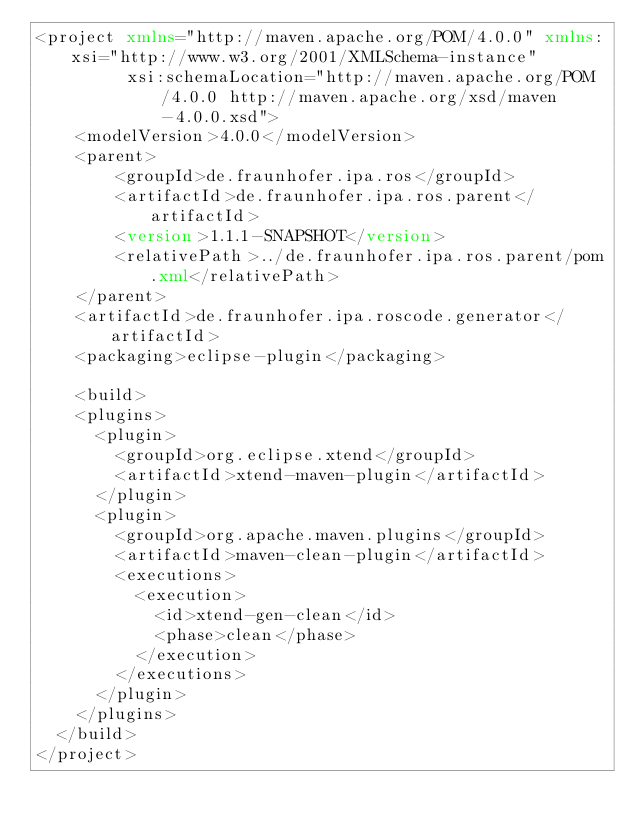<code> <loc_0><loc_0><loc_500><loc_500><_XML_><project xmlns="http://maven.apache.org/POM/4.0.0" xmlns:xsi="http://www.w3.org/2001/XMLSchema-instance"
         xsi:schemaLocation="http://maven.apache.org/POM/4.0.0 http://maven.apache.org/xsd/maven-4.0.0.xsd">
    <modelVersion>4.0.0</modelVersion>
    <parent>
        <groupId>de.fraunhofer.ipa.ros</groupId>
        <artifactId>de.fraunhofer.ipa.ros.parent</artifactId>
        <version>1.1.1-SNAPSHOT</version>
        <relativePath>../de.fraunhofer.ipa.ros.parent/pom.xml</relativePath>
    </parent>
    <artifactId>de.fraunhofer.ipa.roscode.generator</artifactId>
    <packaging>eclipse-plugin</packaging>

    <build>
		<plugins>
			<plugin>
				<groupId>org.eclipse.xtend</groupId>
				<artifactId>xtend-maven-plugin</artifactId>
			</plugin>
			<plugin>
				<groupId>org.apache.maven.plugins</groupId>
				<artifactId>maven-clean-plugin</artifactId>
				<executions>
					<execution>
						<id>xtend-gen-clean</id>
						<phase>clean</phase>
					</execution>
				</executions>
			</plugin>
		</plugins>
	</build>
</project>
</code> 